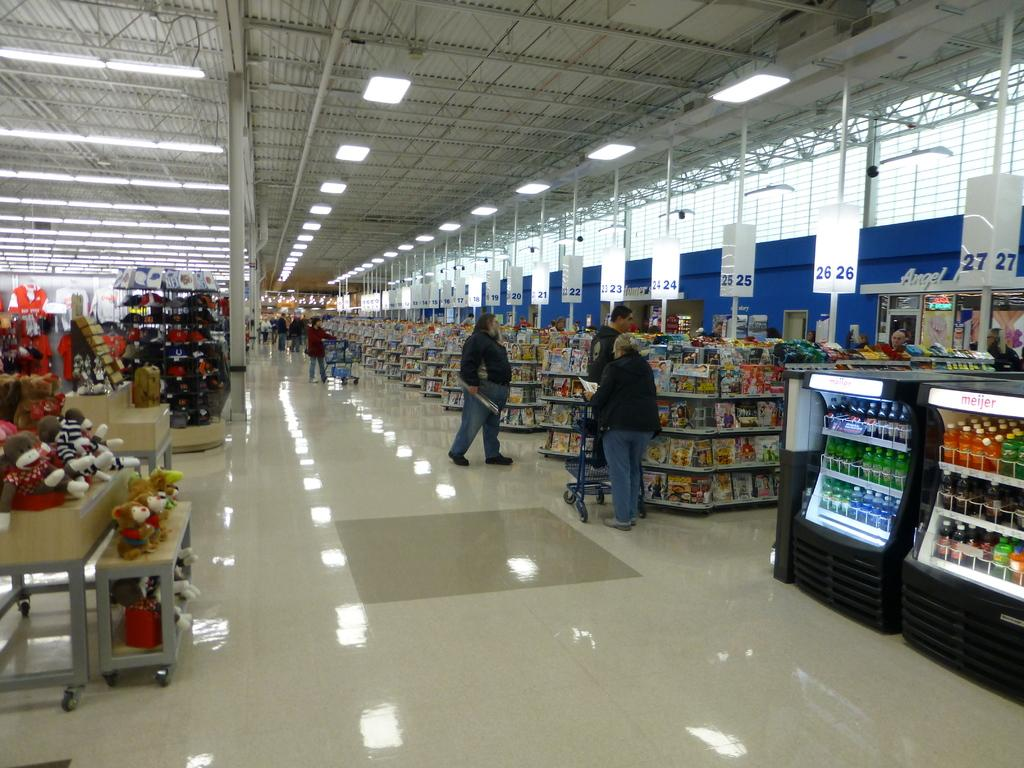Provide a one-sentence caption for the provided image. A line is building in a grocery store at cash register 26. 